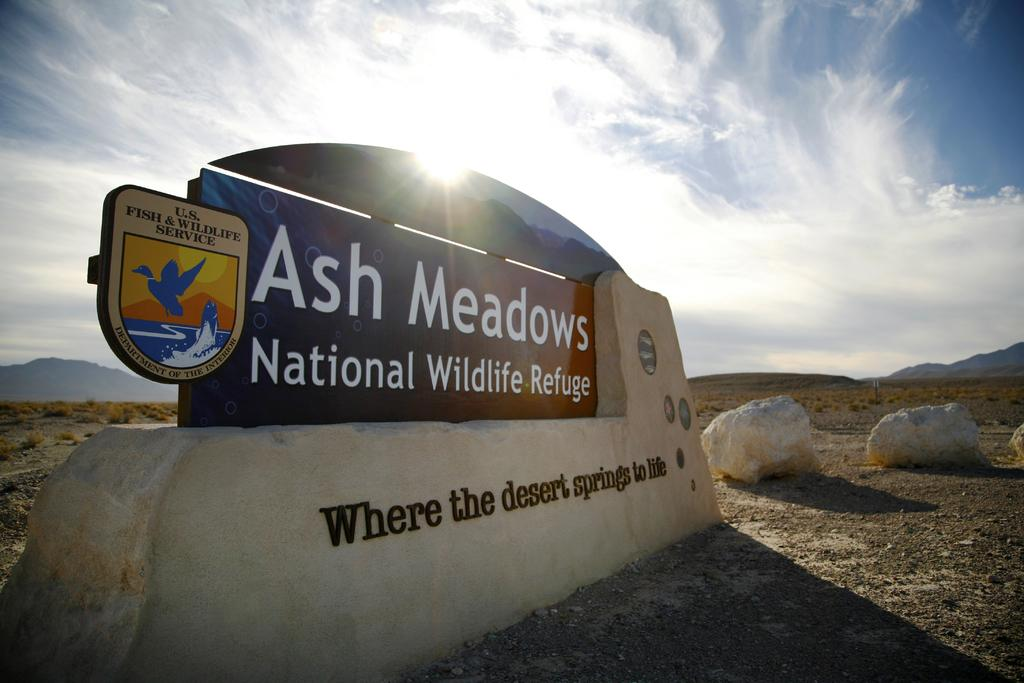What is on the board that is visible in the image? There is a board with text in the image. What type of landscape is visible in the background of the image? Land is visible in the background of the image. What is the color of the sky in the image? The sky is blue in color. What other features can be seen in the sky? There are clouds in the sky. Is there any celestial body visible in the sky? Yes, the sun is visible in the sky. Can you tell me how many snakes are slithering on the board in the image? There are no snakes present in the image; the board has text on it. What type of angle is the board positioned at in the image? The angle at which the board is positioned cannot be determined from the image, as it is a two-dimensional representation. 